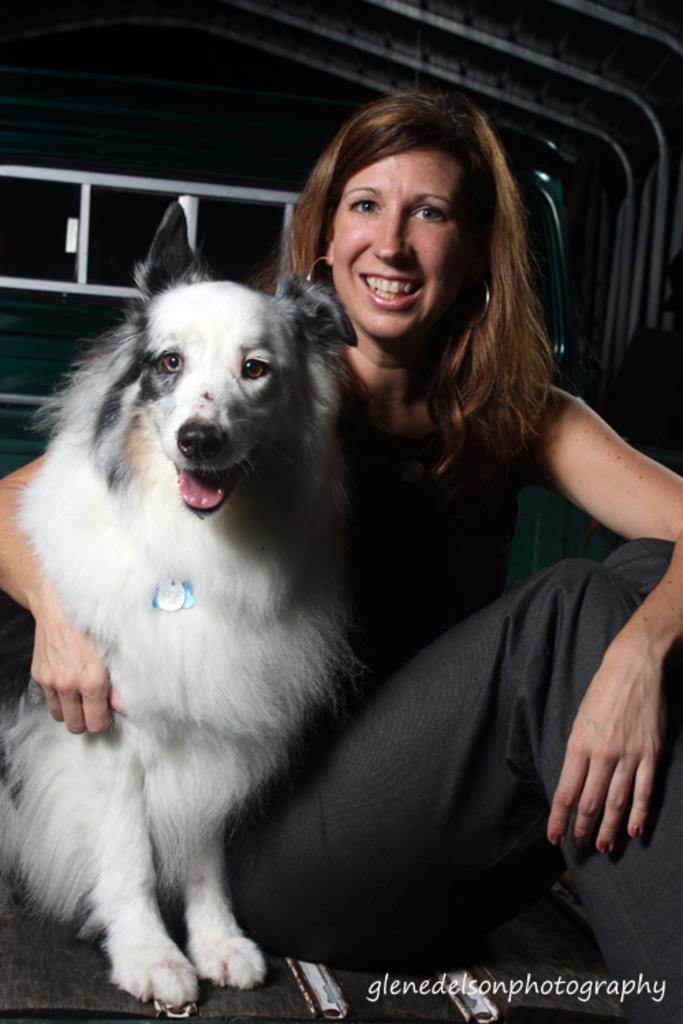How would you summarize this image in a sentence or two? Woman sitting near the dog. 